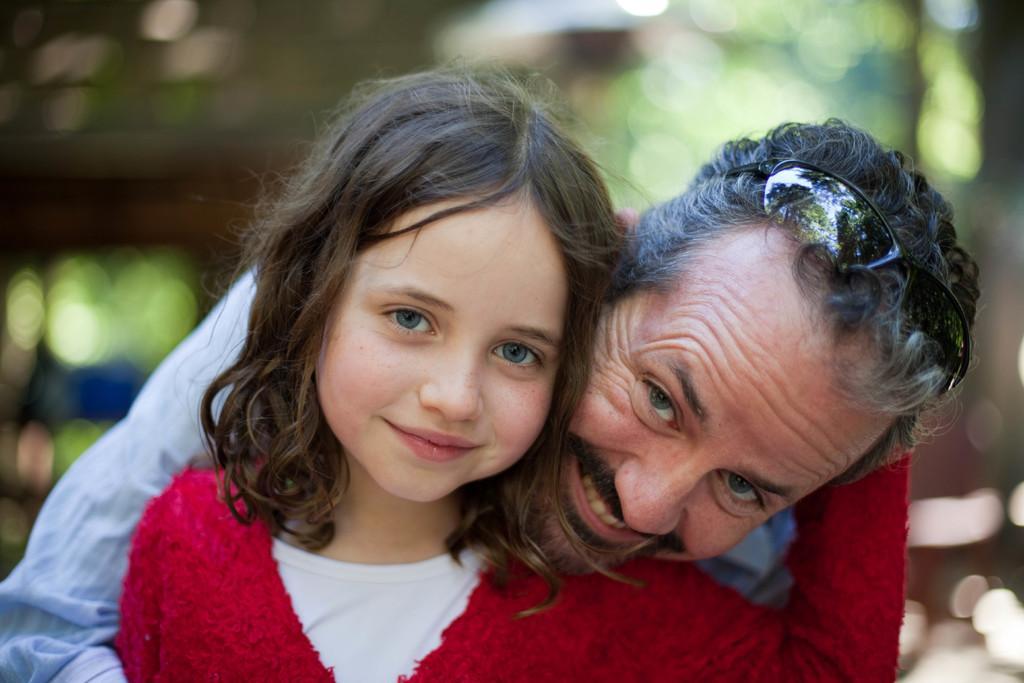Describe this image in one or two sentences. In the foreground of this image, there is a girl in red dress. Behind her, there is a man and the background image is blur. 